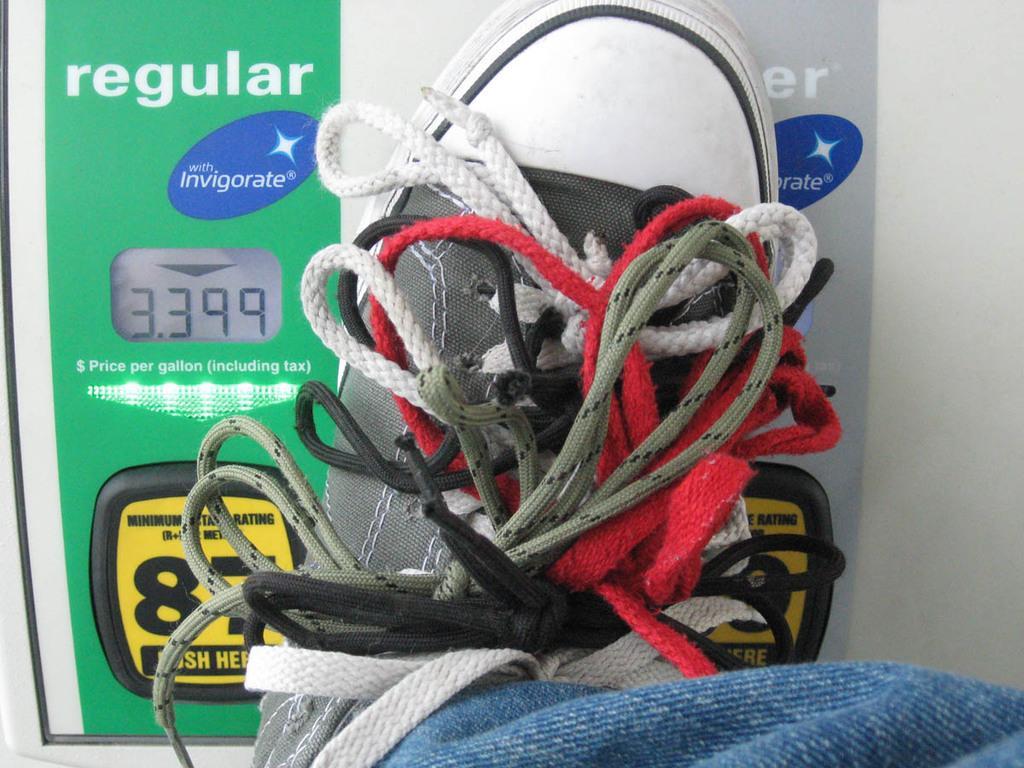Please provide a concise description of this image. In this picture we can see a shoe and few shoelaces. 